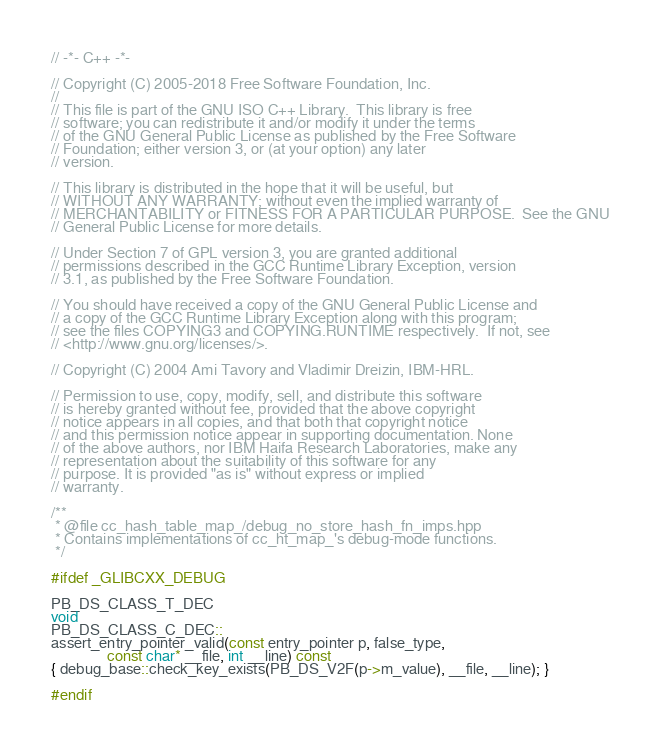<code> <loc_0><loc_0><loc_500><loc_500><_C++_>// -*- C++ -*-

// Copyright (C) 2005-2018 Free Software Foundation, Inc.
//
// This file is part of the GNU ISO C++ Library.  This library is free
// software; you can redistribute it and/or modify it under the terms
// of the GNU General Public License as published by the Free Software
// Foundation; either version 3, or (at your option) any later
// version.

// This library is distributed in the hope that it will be useful, but
// WITHOUT ANY WARRANTY; without even the implied warranty of
// MERCHANTABILITY or FITNESS FOR A PARTICULAR PURPOSE.  See the GNU
// General Public License for more details.

// Under Section 7 of GPL version 3, you are granted additional
// permissions described in the GCC Runtime Library Exception, version
// 3.1, as published by the Free Software Foundation.

// You should have received a copy of the GNU General Public License and
// a copy of the GCC Runtime Library Exception along with this program;
// see the files COPYING3 and COPYING.RUNTIME respectively.  If not, see
// <http://www.gnu.org/licenses/>.

// Copyright (C) 2004 Ami Tavory and Vladimir Dreizin, IBM-HRL.

// Permission to use, copy, modify, sell, and distribute this software
// is hereby granted without fee, provided that the above copyright
// notice appears in all copies, and that both that copyright notice
// and this permission notice appear in supporting documentation. None
// of the above authors, nor IBM Haifa Research Laboratories, make any
// representation about the suitability of this software for any
// purpose. It is provided "as is" without express or implied
// warranty.

/**
 * @file cc_hash_table_map_/debug_no_store_hash_fn_imps.hpp
 * Contains implementations of cc_ht_map_'s debug-mode functions.
 */

#ifdef _GLIBCXX_DEBUG

PB_DS_CLASS_T_DEC
void
PB_DS_CLASS_C_DEC::
assert_entry_pointer_valid(const entry_pointer p, false_type,
			   const char* __file, int __line) const
{ debug_base::check_key_exists(PB_DS_V2F(p->m_value), __file, __line); }

#endif
</code> 